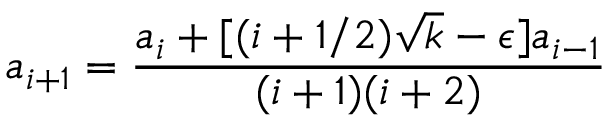Convert formula to latex. <formula><loc_0><loc_0><loc_500><loc_500>a _ { i + 1 } = \frac { a _ { i } + [ ( i + 1 / 2 ) \sqrt { k } - \epsilon ] a _ { i - 1 } } { ( i + 1 ) ( i + 2 ) }</formula> 